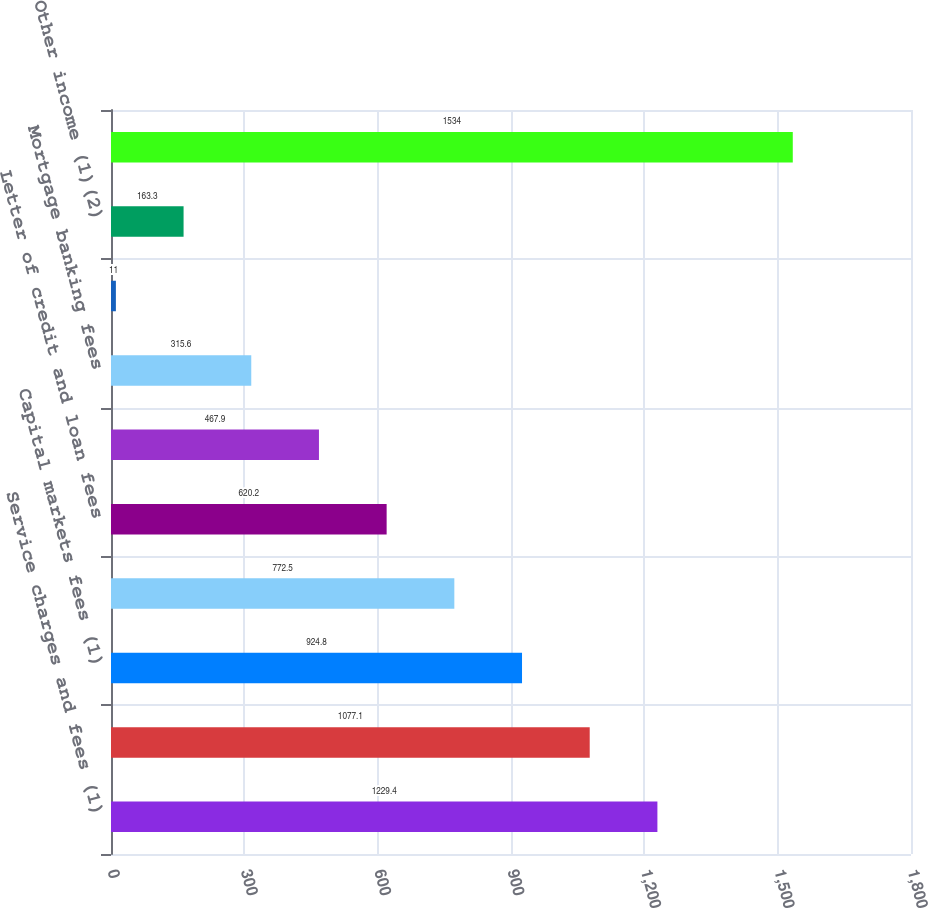Convert chart to OTSL. <chart><loc_0><loc_0><loc_500><loc_500><bar_chart><fcel>Service charges and fees (1)<fcel>Card fees<fcel>Capital markets fees (1)<fcel>Trust and investment services<fcel>Letter of credit and loan fees<fcel>Foreign exchange and interest<fcel>Mortgage banking fees<fcel>Securities gains net<fcel>Other income (1)(2)<fcel>Noninterest income<nl><fcel>1229.4<fcel>1077.1<fcel>924.8<fcel>772.5<fcel>620.2<fcel>467.9<fcel>315.6<fcel>11<fcel>163.3<fcel>1534<nl></chart> 